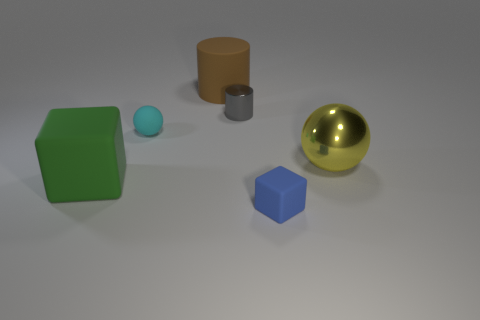Subtract all red balls. Subtract all cyan cylinders. How many balls are left? 2 Add 1 gray metal cubes. How many objects exist? 7 Subtract all balls. How many objects are left? 4 Add 5 large green matte objects. How many large green matte objects exist? 6 Subtract 0 gray cubes. How many objects are left? 6 Subtract all red rubber cubes. Subtract all brown matte cylinders. How many objects are left? 5 Add 1 big cubes. How many big cubes are left? 2 